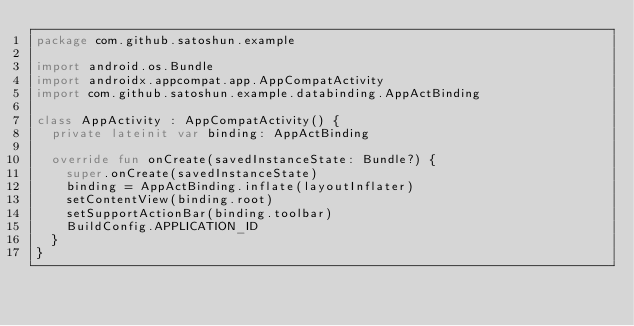Convert code to text. <code><loc_0><loc_0><loc_500><loc_500><_Kotlin_>package com.github.satoshun.example

import android.os.Bundle
import androidx.appcompat.app.AppCompatActivity
import com.github.satoshun.example.databinding.AppActBinding

class AppActivity : AppCompatActivity() {
  private lateinit var binding: AppActBinding

  override fun onCreate(savedInstanceState: Bundle?) {
    super.onCreate(savedInstanceState)
    binding = AppActBinding.inflate(layoutInflater)
    setContentView(binding.root)
    setSupportActionBar(binding.toolbar)
    BuildConfig.APPLICATION_ID
  }
}
</code> 